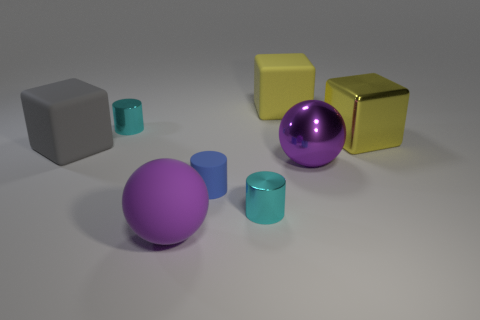Do the yellow block on the left side of the purple metal ball and the blue rubber thing to the left of the big yellow rubber thing have the same size?
Provide a succinct answer. No. What size is the purple shiny object that is the same shape as the purple matte object?
Ensure brevity in your answer.  Large. There is a big metal cube; is it the same color as the big matte cube that is right of the big gray rubber thing?
Ensure brevity in your answer.  Yes. Are there more big rubber things that are behind the large gray cube than large matte spheres to the right of the purple matte object?
Your response must be concise. Yes. What number of balls have the same material as the blue cylinder?
Make the answer very short. 1. Does the tiny shiny thing that is in front of the yellow shiny object have the same shape as the yellow rubber object behind the tiny blue cylinder?
Your answer should be very brief. No. There is a tiny thing on the right side of the small matte thing; what color is it?
Your answer should be very brief. Cyan. Are there any cyan metallic things that have the same shape as the blue matte object?
Give a very brief answer. Yes. There is a matte thing that is on the right side of the large rubber sphere and in front of the yellow rubber block; what is its size?
Offer a very short reply. Small. There is another ball that is the same color as the large metallic sphere; what material is it?
Your answer should be compact. Rubber. 